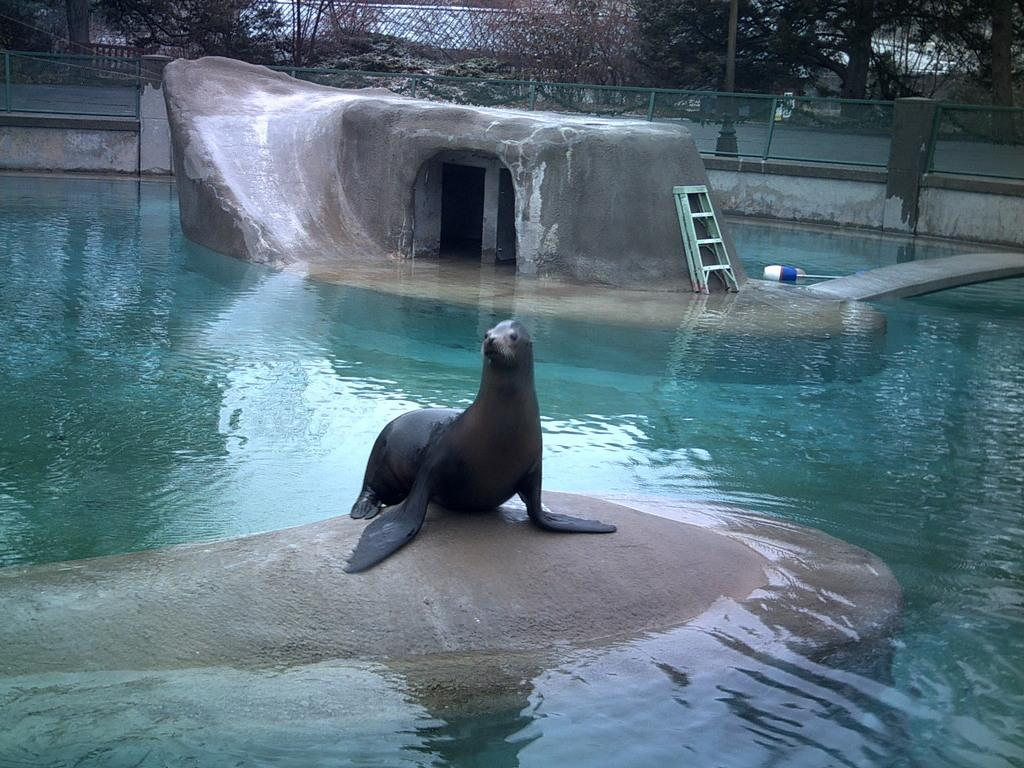What can be seen in the background of the image? In the background, there is a mesh, trees, and a pole. What natural feature is present in the image? There is a cave in the image. What man-made object is in the image? There is a ladder in the image. What is the main object in the image? There is an object in the image. What type of environment is depicted in the image? There is water in the image. What animal is present in the image? There is an animal called a seal in the image. Where is the seal located in the image? The seal is on a surface. What type of yoke is being used by the seal in the image? There is no yoke present in the image; the seal is on a surface. How many pages are visible in the image? There are no pages present in the image. 